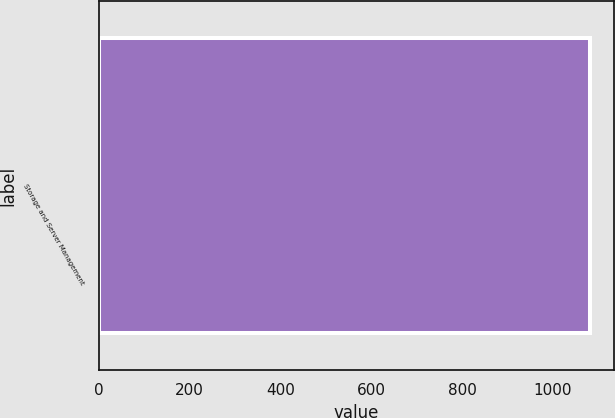Convert chart. <chart><loc_0><loc_0><loc_500><loc_500><bar_chart><fcel>Storage and Server Management<nl><fcel>1081<nl></chart> 